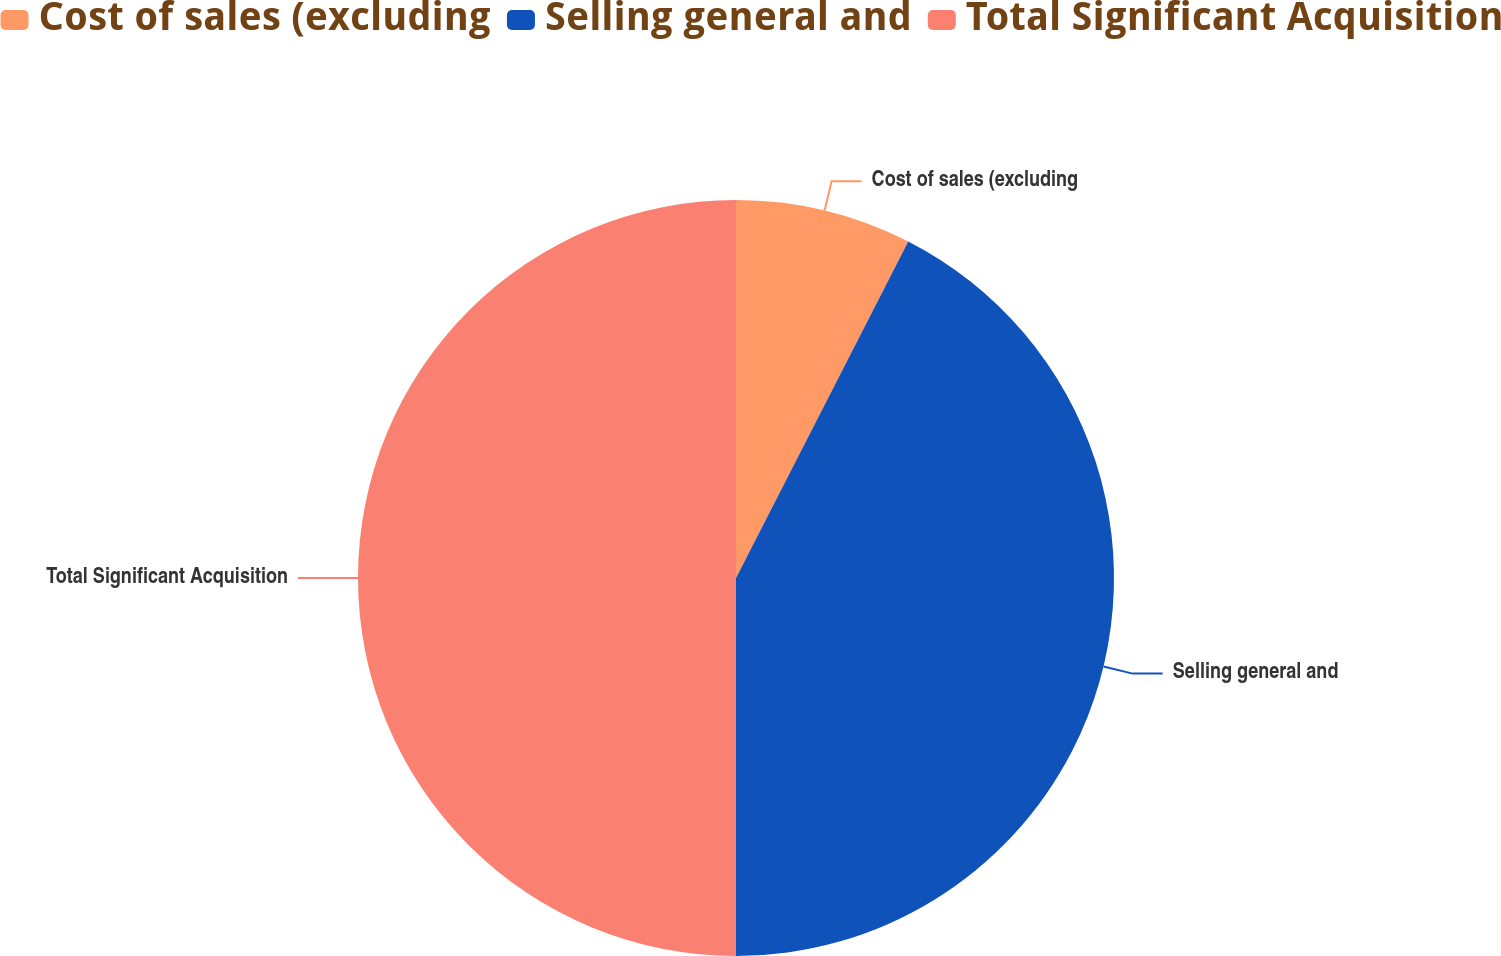Convert chart to OTSL. <chart><loc_0><loc_0><loc_500><loc_500><pie_chart><fcel>Cost of sales (excluding<fcel>Selling general and<fcel>Total Significant Acquisition<nl><fcel>7.53%<fcel>42.47%<fcel>50.0%<nl></chart> 